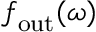Convert formula to latex. <formula><loc_0><loc_0><loc_500><loc_500>f _ { o u t } ( \omega )</formula> 